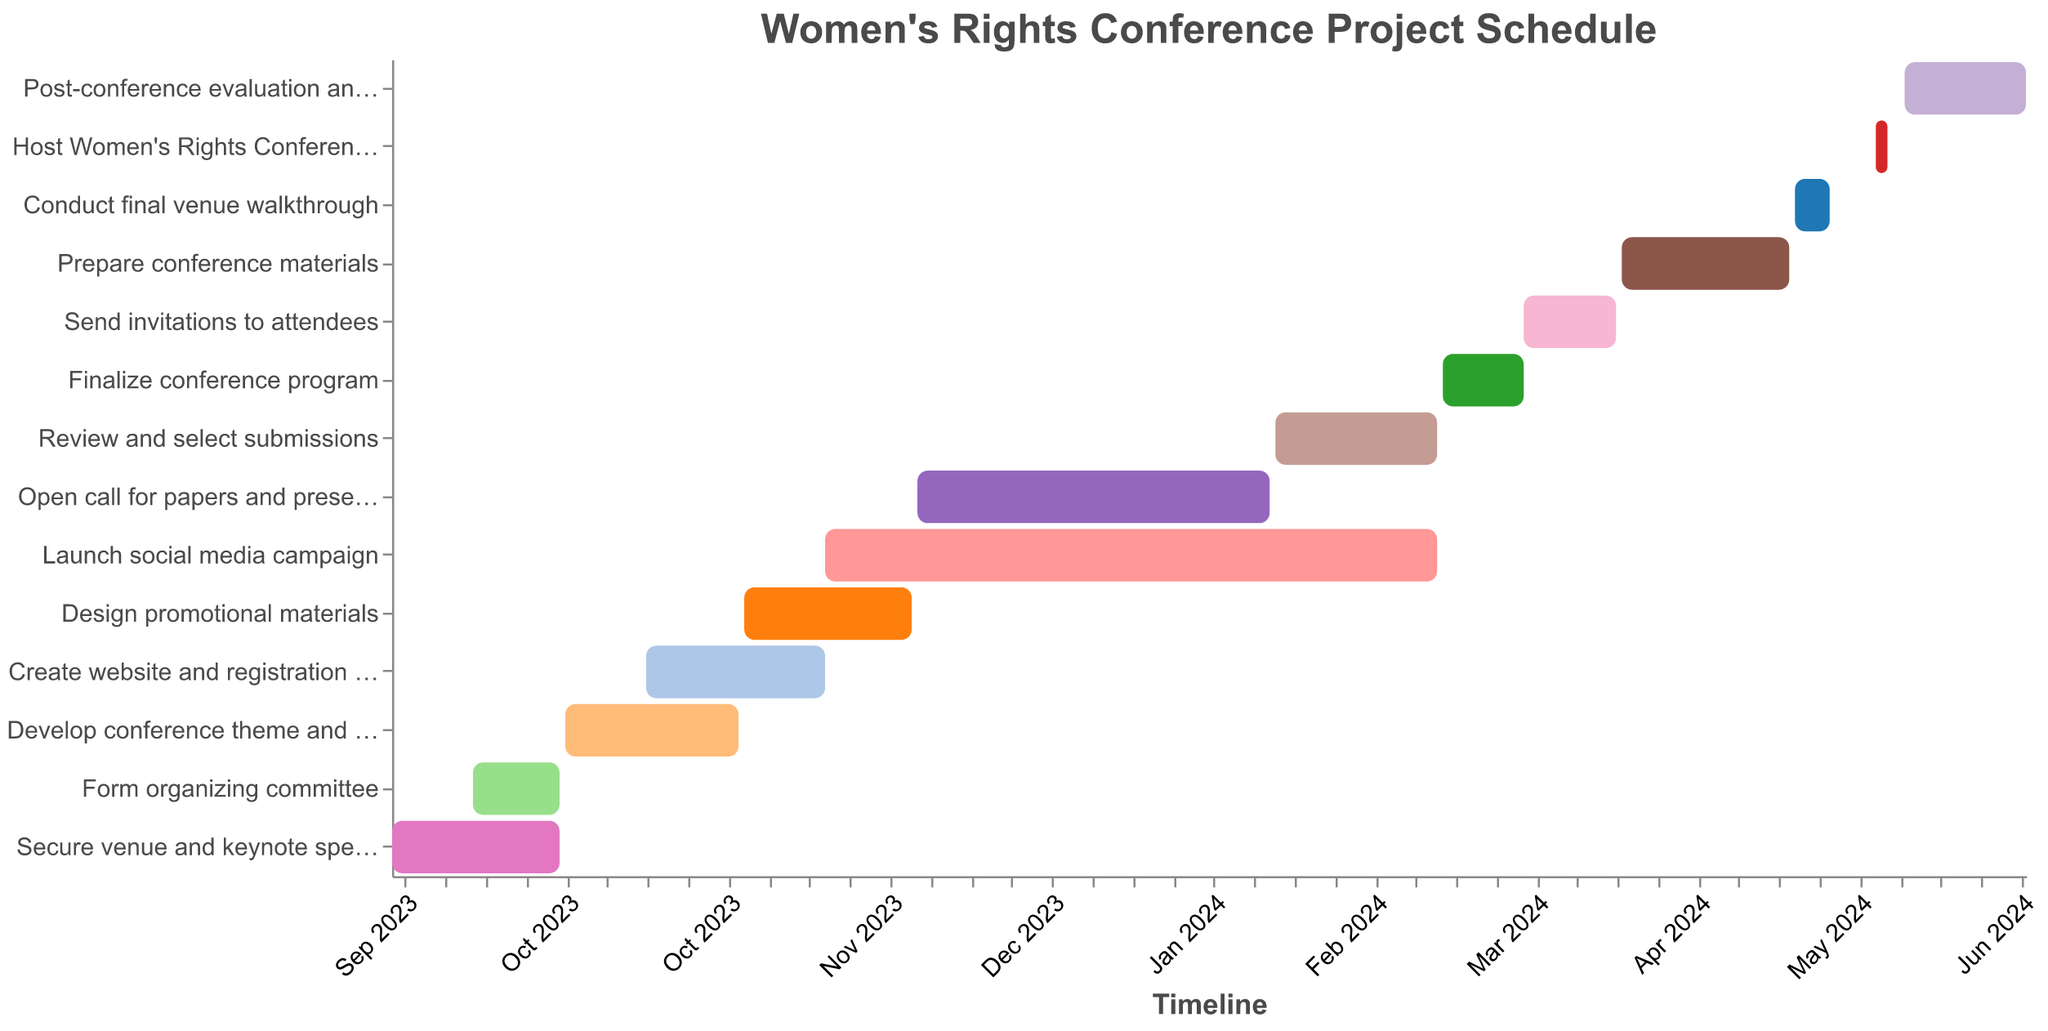What is the duration for securing the venue and keynote speakers? To find the duration, we need to look at the Gantt chart and note the start and end dates for this task. The task "Secure venue and keynote speakers" starts on September 1, 2023, and ends on September 30, 2023. There are 30 days in September, so the duration is 30 days.
Answer: 30 days What tasks are planned to run concurrently with developing the conference theme and agenda? We need to look at the Gantt chart and identify tasks whose date ranges overlap with "Develop conference theme and agenda" (October 1, 2023, to October 31, 2023). The tasks overlapping are "Create website and registration system" (October 15, 2023, to November 15, 2023).
Answer: Create website and registration system How many days does the review and selection of submissions take? The "Review and select submissions" task starts on February 1, 2024, and ends on February 29, 2024. Considering February 2024 is a leap year, it has 29 days. Therefore, the task duration is 29 days.
Answer: 29 days Between which two tasks does the social media campaign launch? To find this, we observe the tasks before and after the "Launch social media campaign" task (November 15, 2023, to February 29, 2024). The tasks immediately before are "Create website and registration system" (October 15, 2023, to November 15, 2023) and "Design promotional materials" (November 1, 2023, to November 30, 2023).
Answer: Create website and registration system and Design promotional materials How does the duration of preparing conference materials compare to finalizing the conference program? To answer this, we need to find the duration of both tasks. "Prepare conference materials" runs from April 1, 2024, to April 30, 2024, a total of 30 days. "Finalize conference program" runs from March 1, 2024, to March 15, 2024, a total of 15 days. Comparing the two, 30 days is greater than 15 days.
Answer: Preparing conference materials duration is longer (30 days vs. 15 days) What is the shortest task duration and which task has this duration? We need to check the duration of all tasks. The task "Form organizing committee" runs from September 15, 2023, to September 30, 2023, which is 15 days, the shortest among all tasks.
Answer: Form organizing committee (15 days) When does the post-conference evaluation and report start? We look at the Gantt chart to find the start date of the "Post-conference evaluation and report" task. It starts on May 20, 2024.
Answer: May 20, 2024 What is the total duration from the start of securing the venue to the end of the conference? The first task starts on September 1, 2023, and the conference ends on May 17, 2024. The total duration including both dates is calculated as the difference between May 17, 2024, and September 1, 2023, which is 260 days.
Answer: 260 days Which task overlaps with both November 2023 and January 2024? The task that overlaps both November 2023 and January 2024 is "Launch social media campaign", which runs from November 15, 2023, to February 29, 2024.
Answer: Launch social media campaign 